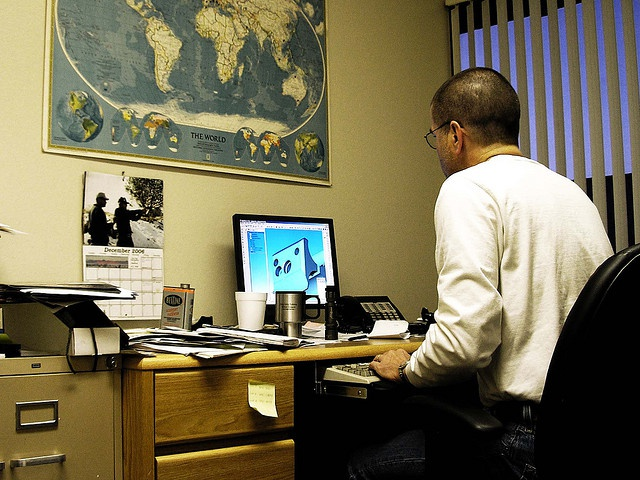Describe the objects in this image and their specific colors. I can see people in khaki, ivory, black, and tan tones, chair in khaki, black, gray, darkgreen, and tan tones, tv in khaki, white, cyan, black, and lightblue tones, cup in khaki, black, darkgreen, tan, and ivory tones, and keyboard in khaki, olive, and black tones in this image. 